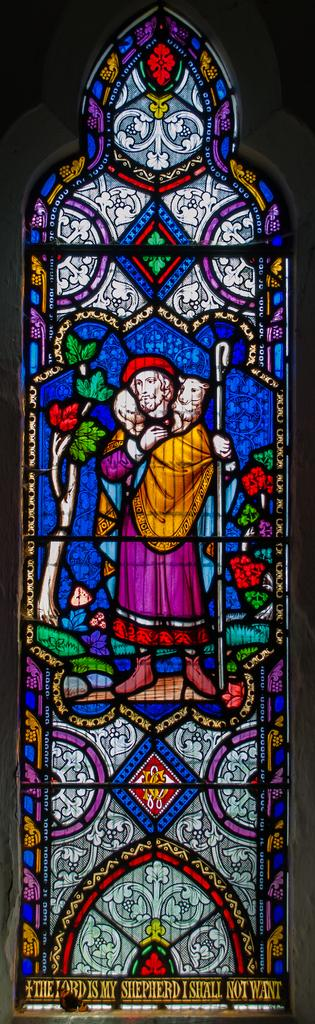What type of glass is depicted in the image? There is a stained glass in the image. What is written or depicted on the stained glass? There is text on the stained glass. What type of company is represented by the stained glass in the image? There is no company represented by the stained glass in the image; it only features text and is not associated with any specific company. 